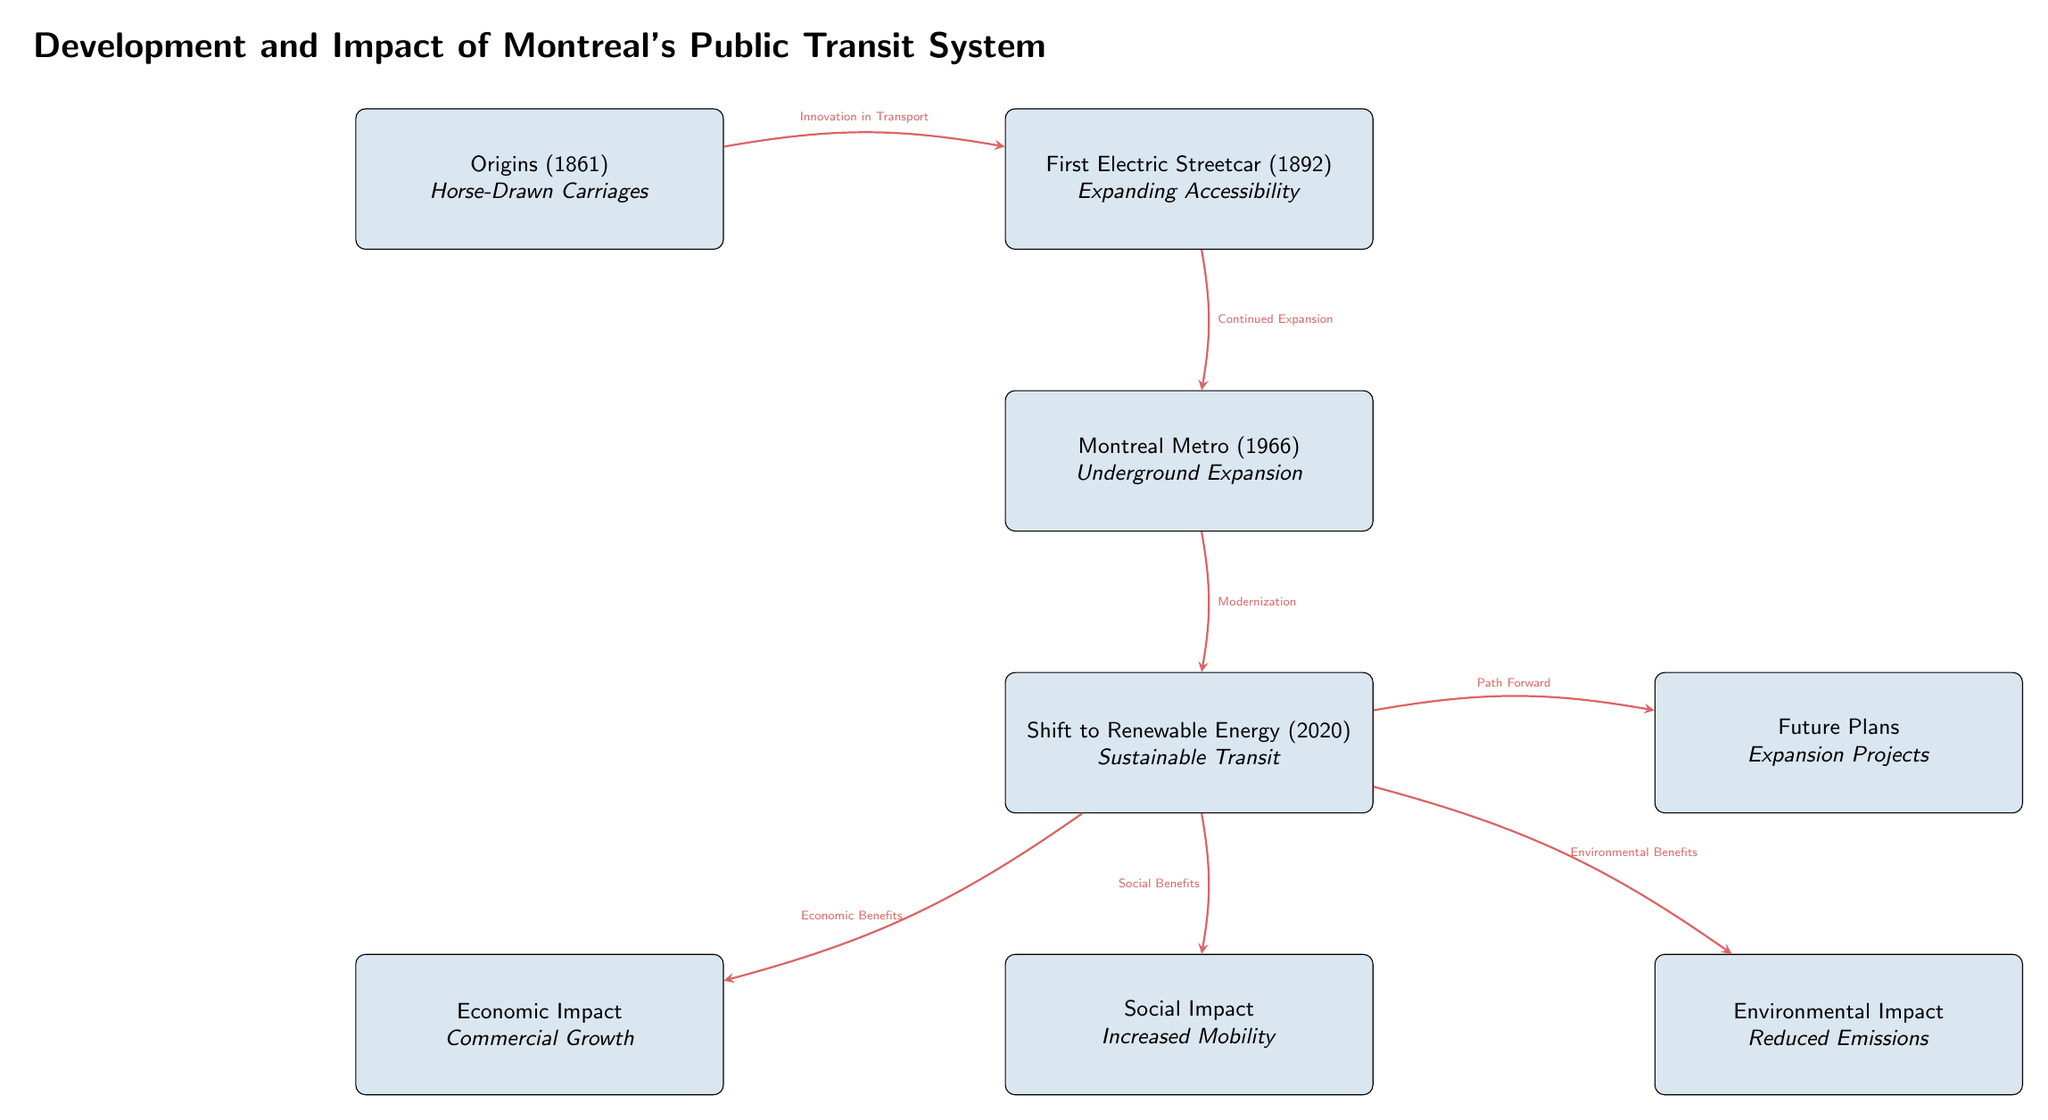What year did the Montreal Metro open? The diagram states that the Montreal Metro was established in 1966, so we look directly at the node labeled "Montreal Metro (1966)" to find the year.
Answer: 1966 What does the "Origins" node represent? The node labeled "Origins (1861)" mentions "Horse-Drawn Carriages," indicating that this was the initial form of public transit in Montreal which is shown at the top of the diagram.
Answer: Horse-Drawn Carriages What are the impacts connected to the "Shift to Renewable Energy"? The diagram illustrates three impacts stemming from "Shift to Renewable Energy," which are labeled as Economic Impact, Social Impact, and Environmental Impact, all flowing from this node.
Answer: Economic Impact, Social Impact, Environmental Impact How many total nodes are present in the diagram? Counting all the boxes in the diagram reveals there are seven distinct nodes regarding the development and impacts of Montreal's public transit system.
Answer: 7 What is a benefit linked to the "Shift to Renewable Energy"? The arrows stemming from "Shift to Renewable Energy" indicate various benefits. Specifically, there are labels for Economic Benefits, Social Benefits, and Environmental Benefits; each represents a different aspect of the impacts.
Answer: Economic Benefits What pathway connects the first electric streetcar to the Montreal Metro? The diagram shows an arrow between "First Electric Streetcar (1892)" and "Montreal Metro (1966)" indicating the relationship is characterized by "Continued Expansion," which signifies that the introduction of the electric streetcar led to the development of the metro system.
Answer: Continued Expansion What is indicated as the future direction associated with the "Shift to Renewable Energy"? The diagram shows that from the "Shift to Renewable Energy" node, there is a connection to a node labeled "Future Plans," suggesting that this transition towards renewable energy includes upcoming expansion projects for public transit.
Answer: Expansion Projects What type of transport innovation began in 1861? The "Origins (1861)" node specifies a transition in transport innovation from horse-drawn methods, highlighting the initial establishment of public transport before the advent of electric systems.
Answer: Horse-Drawn Carriages 